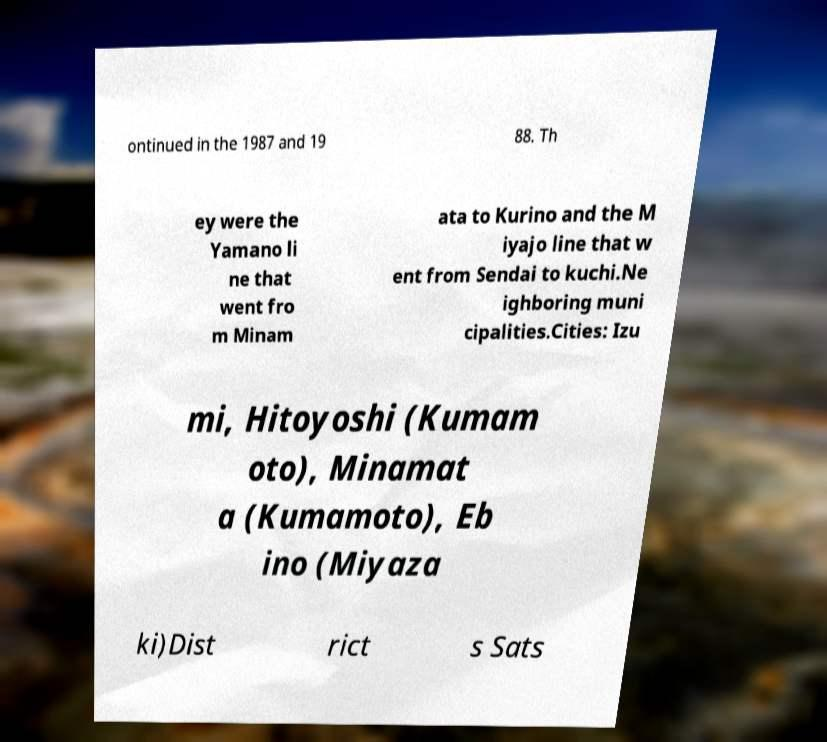There's text embedded in this image that I need extracted. Can you transcribe it verbatim? ontinued in the 1987 and 19 88. Th ey were the Yamano li ne that went fro m Minam ata to Kurino and the M iyajo line that w ent from Sendai to kuchi.Ne ighboring muni cipalities.Cities: Izu mi, Hitoyoshi (Kumam oto), Minamat a (Kumamoto), Eb ino (Miyaza ki)Dist rict s Sats 